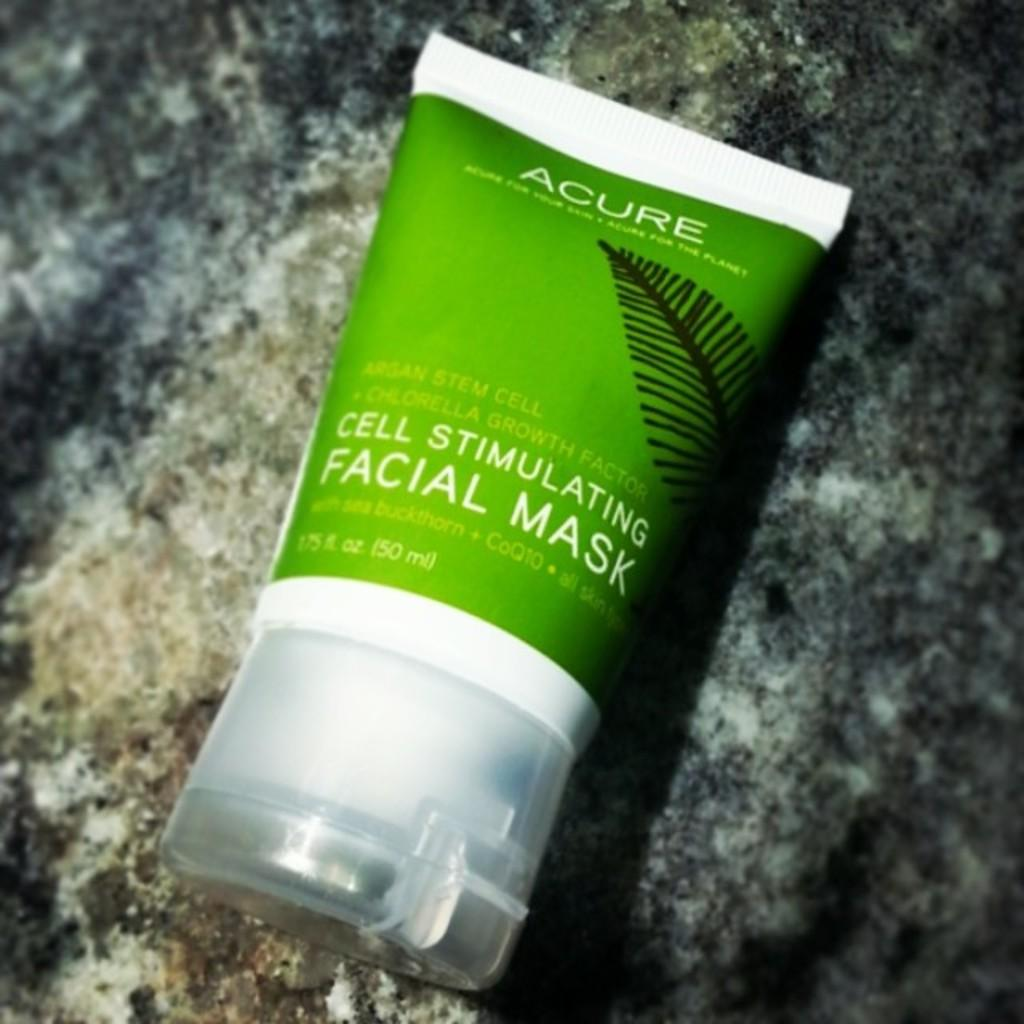Provide a one-sentence caption for the provided image. Green and white bottle of Acure cell stimulating facial mask. 